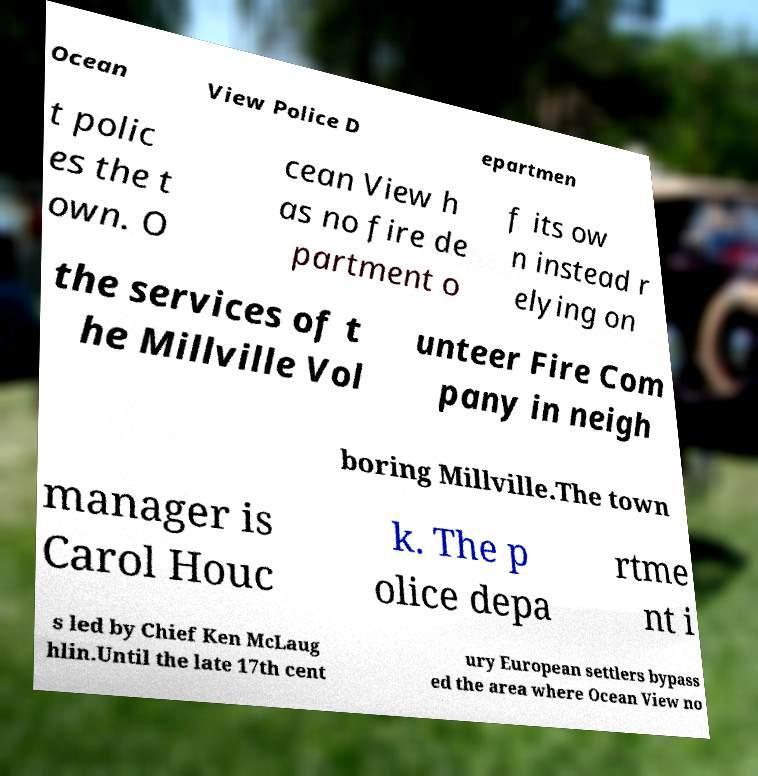Could you extract and type out the text from this image? Ocean View Police D epartmen t polic es the t own. O cean View h as no fire de partment o f its ow n instead r elying on the services of t he Millville Vol unteer Fire Com pany in neigh boring Millville.The town manager is Carol Houc k. The p olice depa rtme nt i s led by Chief Ken McLaug hlin.Until the late 17th cent ury European settlers bypass ed the area where Ocean View no 